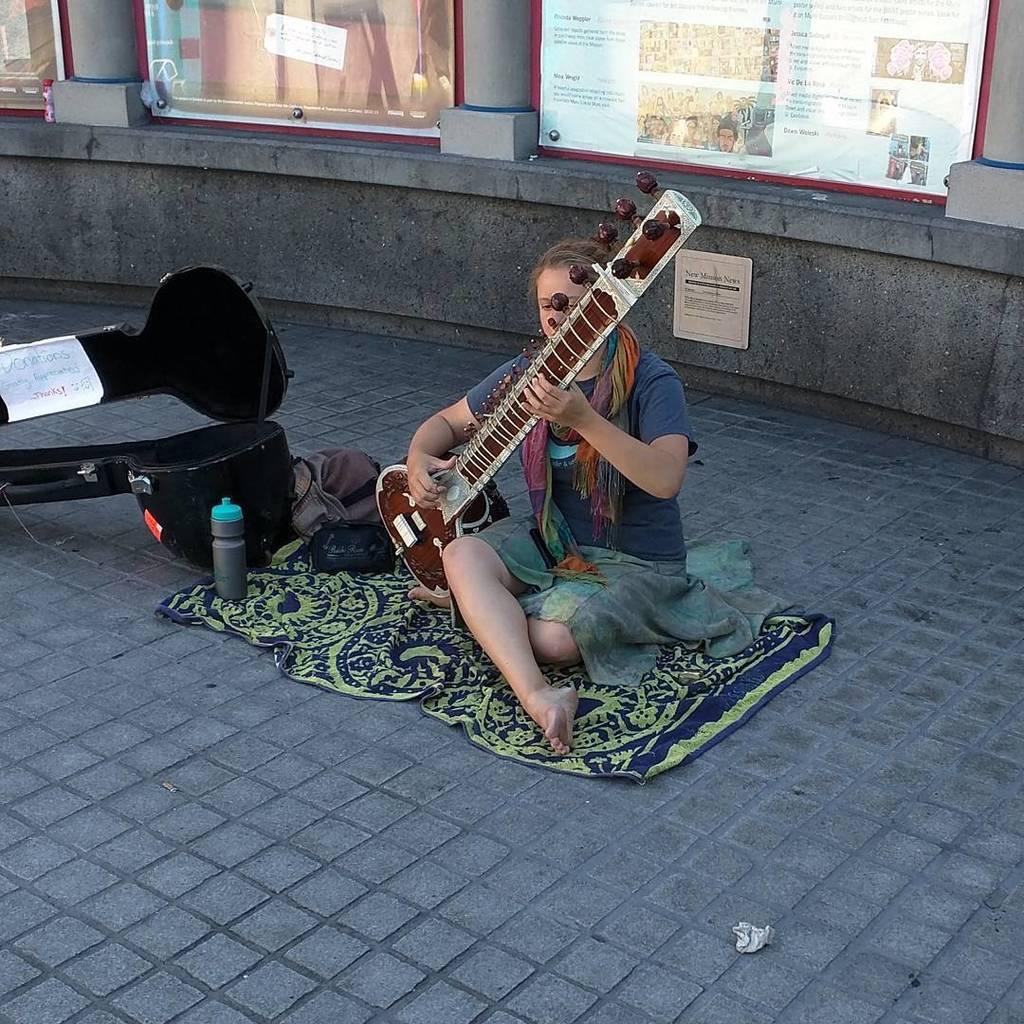Can you describe this image briefly? Here is the women sitting and playing sitara instrument. This is a blanket on the floor. I can see a sitara instrument bag which is black in color. This is the water bottle placed on the floor. At background I can see posts attached to the wall. This is a paper lying on the floor. 